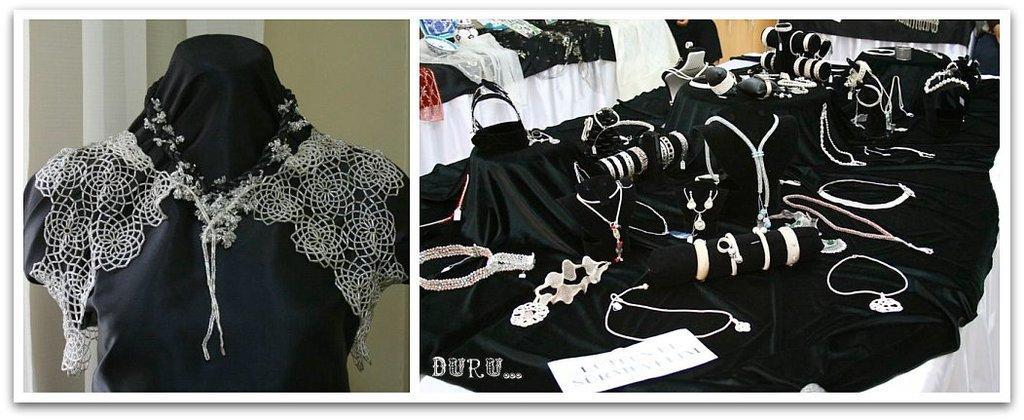Please provide a concise description of this image. There are two images. In the left image we can see a dress and in the right image we can see there are many bangles, neck chains, piece of paper and black and white cloth. 